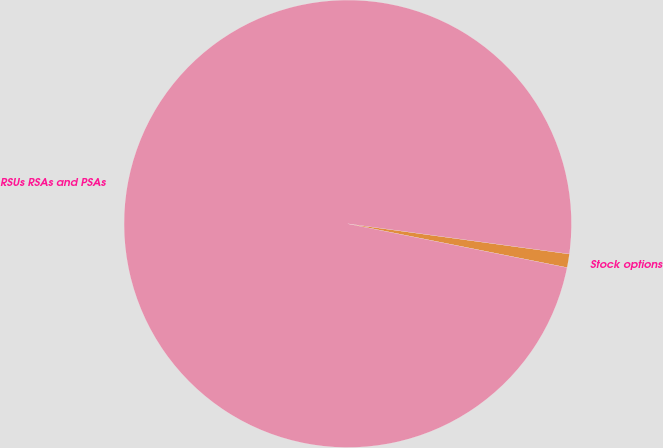Convert chart. <chart><loc_0><loc_0><loc_500><loc_500><pie_chart><fcel>Stock options<fcel>RSUs RSAs and PSAs<nl><fcel>0.98%<fcel>99.02%<nl></chart> 